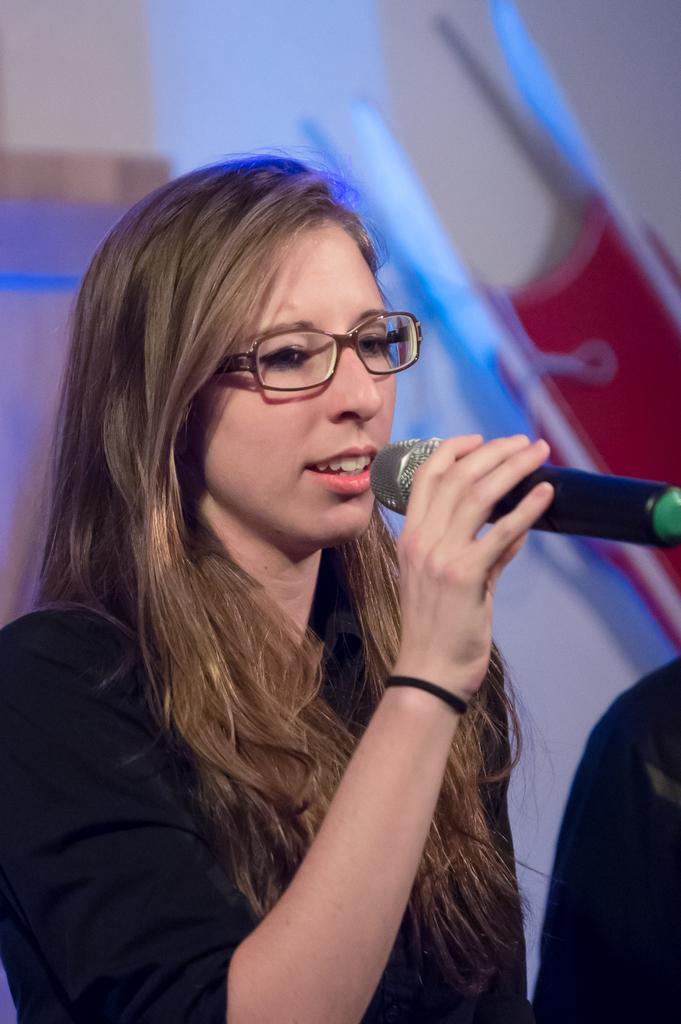Describe this image in one or two sentences. In this picture we can see a woman holding a mike in her hand and talking. She wore spectacles. and we can see a wrist band which is in black colour to her hand. Her hair colour is brown. 